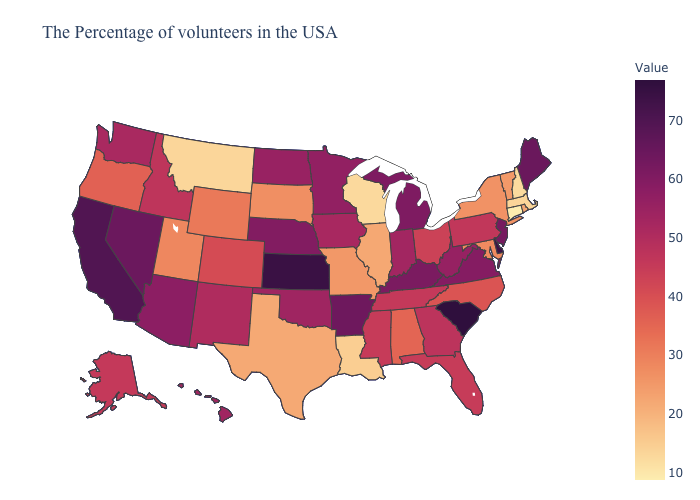Does the map have missing data?
Keep it brief. No. Does Utah have the lowest value in the West?
Write a very short answer. No. Among the states that border Missouri , does Illinois have the lowest value?
Quick response, please. Yes. Which states hav the highest value in the MidWest?
Concise answer only. Kansas. Does South Carolina have the highest value in the USA?
Write a very short answer. Yes. Which states have the lowest value in the USA?
Give a very brief answer. Connecticut. Among the states that border Utah , does Wyoming have the lowest value?
Give a very brief answer. Yes. 